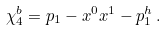<formula> <loc_0><loc_0><loc_500><loc_500>\chi _ { 4 } ^ { b } = p _ { 1 } - x ^ { 0 } x ^ { 1 } - p _ { 1 } ^ { h } \, .</formula> 